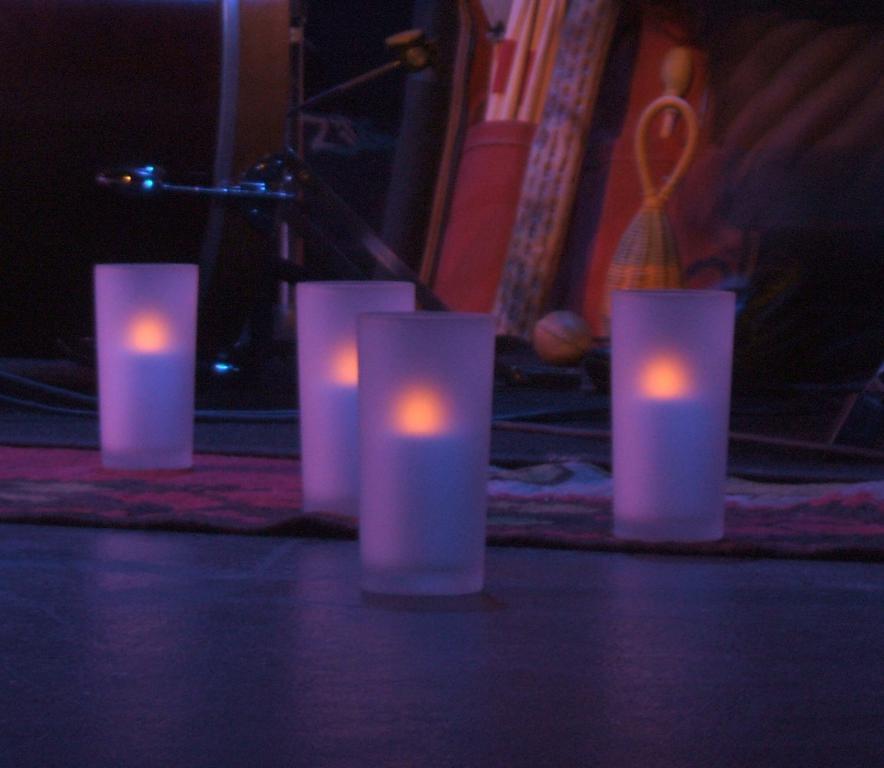Can you describe this image briefly? In this image in the center there are glasses on the ground and in the background there are objects and there is a pillar. 